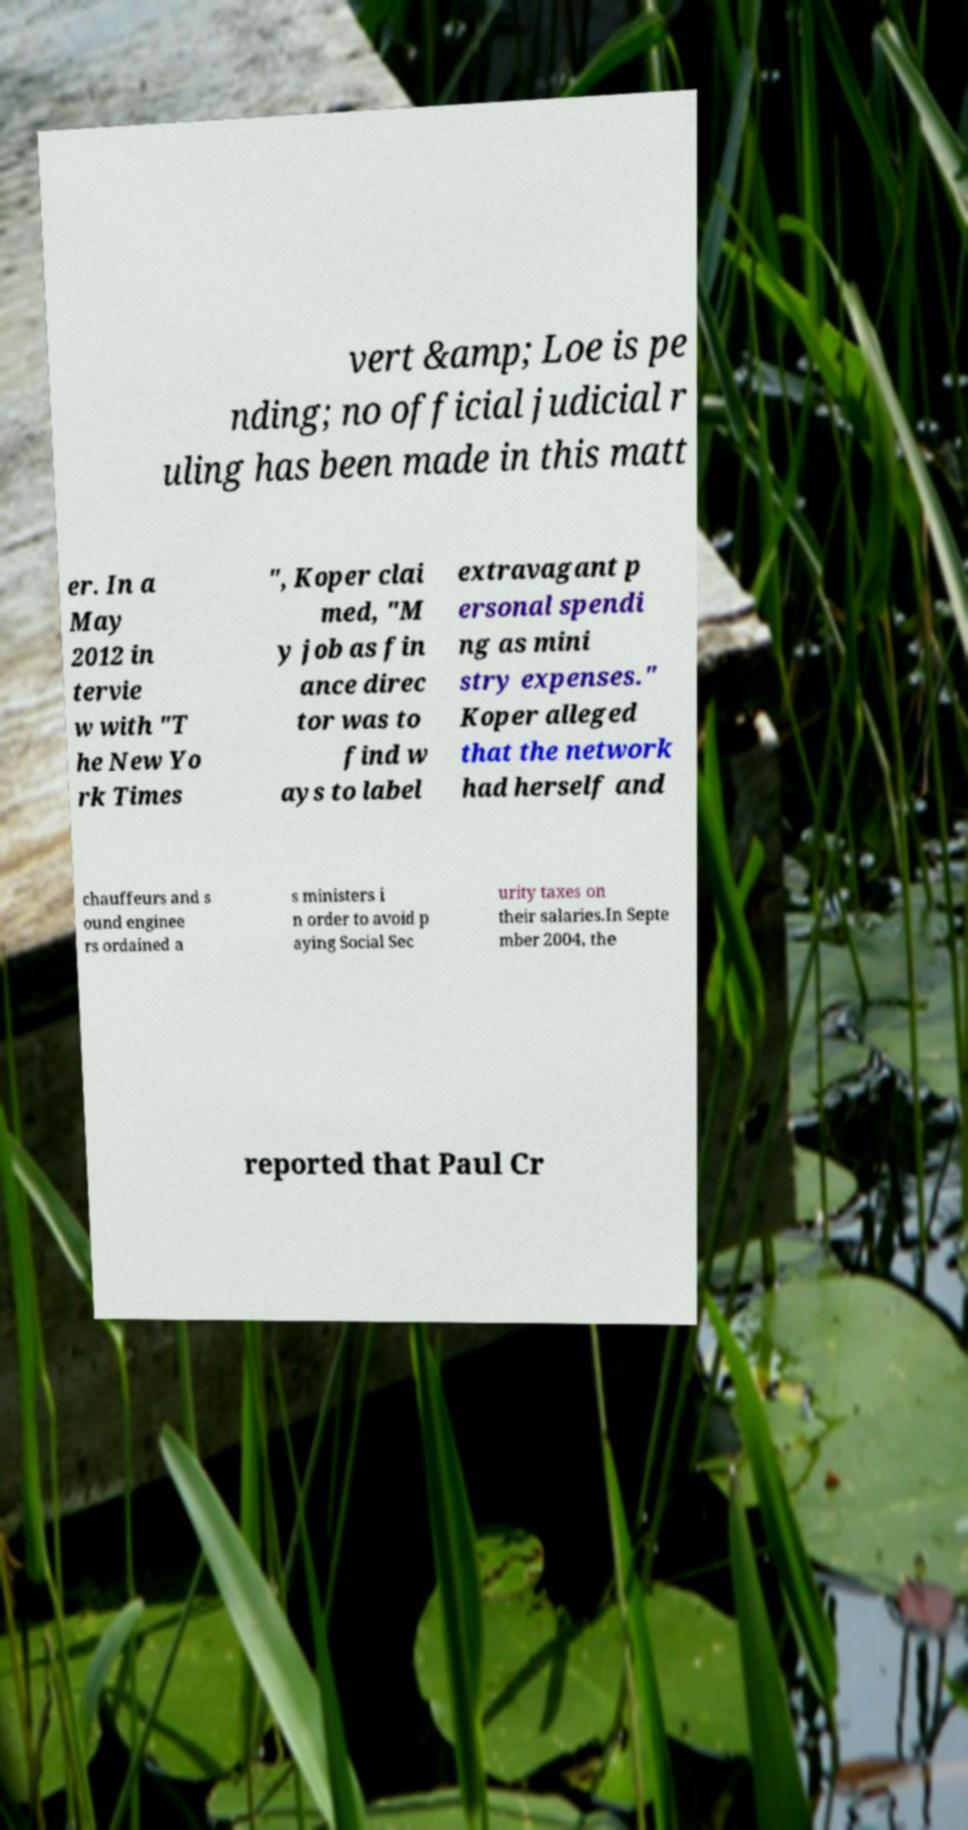Please identify and transcribe the text found in this image. vert &amp; Loe is pe nding; no official judicial r uling has been made in this matt er. In a May 2012 in tervie w with "T he New Yo rk Times ", Koper clai med, "M y job as fin ance direc tor was to find w ays to label extravagant p ersonal spendi ng as mini stry expenses." Koper alleged that the network had herself and chauffeurs and s ound enginee rs ordained a s ministers i n order to avoid p aying Social Sec urity taxes on their salaries.In Septe mber 2004, the reported that Paul Cr 